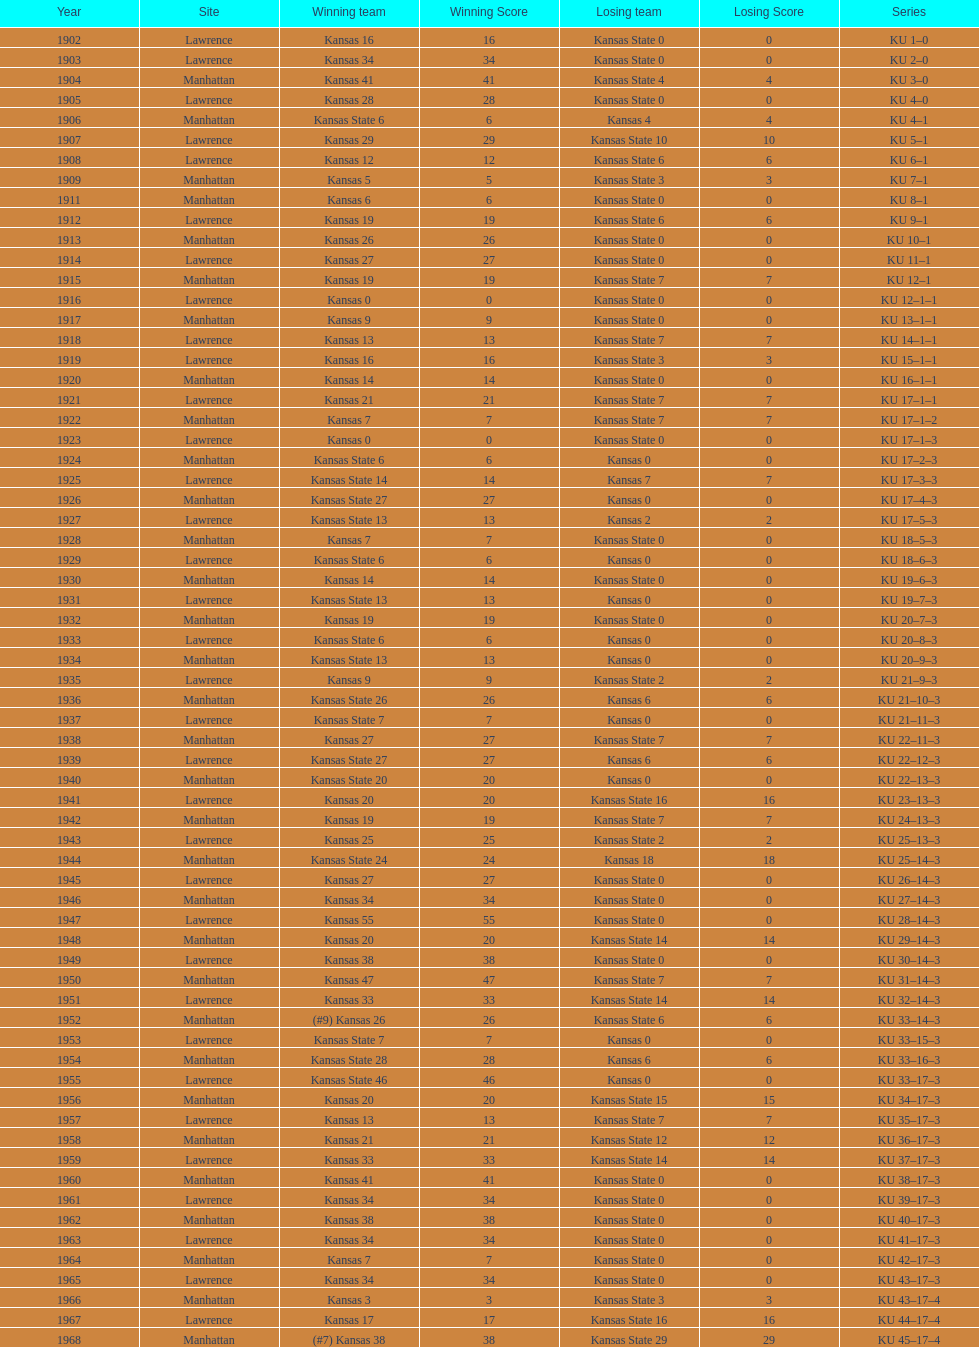What is the total number of games played? 66. 